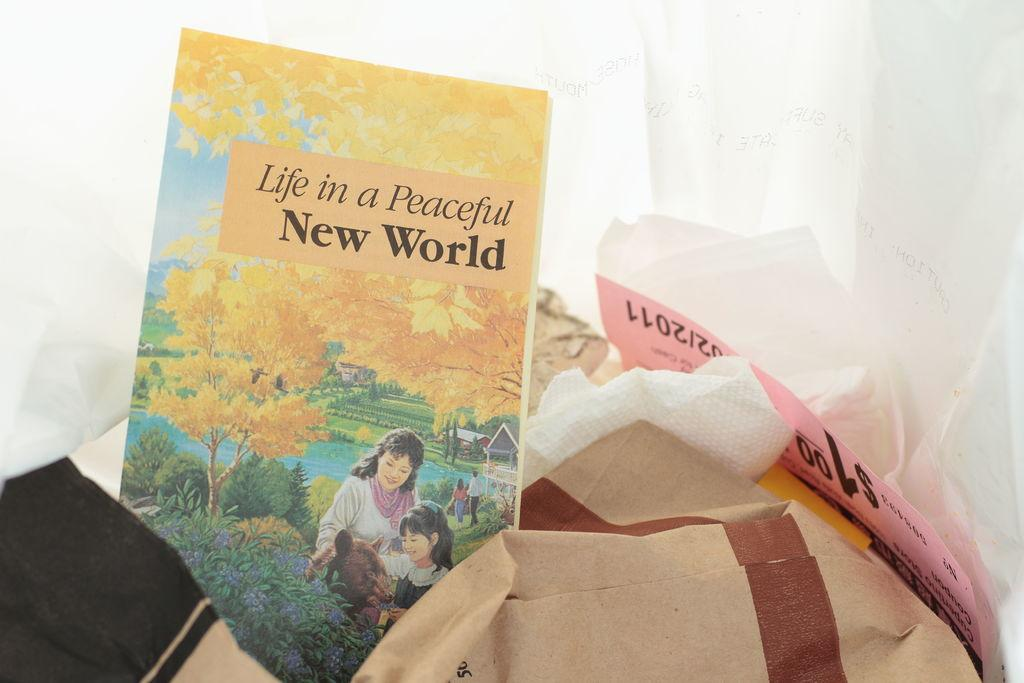<image>
Share a concise interpretation of the image provided. a book that says Life in a Peaceful World 